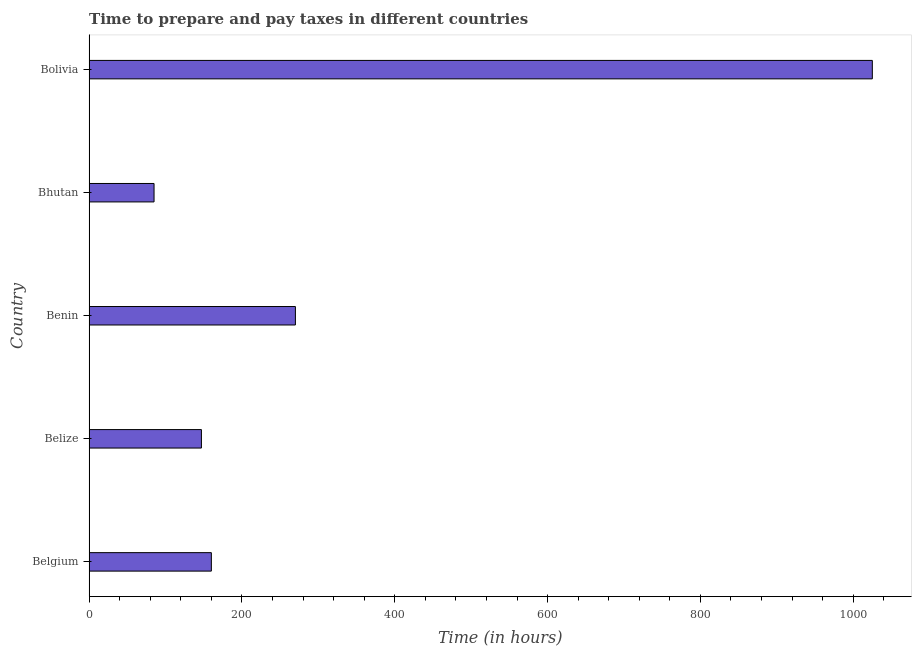Does the graph contain any zero values?
Your answer should be very brief. No. What is the title of the graph?
Make the answer very short. Time to prepare and pay taxes in different countries. What is the label or title of the X-axis?
Offer a very short reply. Time (in hours). What is the label or title of the Y-axis?
Keep it short and to the point. Country. What is the time to prepare and pay taxes in Bolivia?
Your answer should be very brief. 1025. Across all countries, what is the maximum time to prepare and pay taxes?
Provide a short and direct response. 1025. In which country was the time to prepare and pay taxes maximum?
Your answer should be compact. Bolivia. In which country was the time to prepare and pay taxes minimum?
Offer a very short reply. Bhutan. What is the sum of the time to prepare and pay taxes?
Keep it short and to the point. 1687. What is the difference between the time to prepare and pay taxes in Benin and Bhutan?
Keep it short and to the point. 185. What is the average time to prepare and pay taxes per country?
Your response must be concise. 337.4. What is the median time to prepare and pay taxes?
Provide a short and direct response. 160. In how many countries, is the time to prepare and pay taxes greater than 200 hours?
Your response must be concise. 2. What is the ratio of the time to prepare and pay taxes in Belgium to that in Benin?
Offer a terse response. 0.59. Is the time to prepare and pay taxes in Belize less than that in Benin?
Provide a short and direct response. Yes. Is the difference between the time to prepare and pay taxes in Belize and Bhutan greater than the difference between any two countries?
Your response must be concise. No. What is the difference between the highest and the second highest time to prepare and pay taxes?
Your response must be concise. 755. What is the difference between the highest and the lowest time to prepare and pay taxes?
Make the answer very short. 940. How many bars are there?
Keep it short and to the point. 5. What is the difference between two consecutive major ticks on the X-axis?
Your answer should be very brief. 200. What is the Time (in hours) in Belgium?
Offer a terse response. 160. What is the Time (in hours) of Belize?
Provide a succinct answer. 147. What is the Time (in hours) in Benin?
Keep it short and to the point. 270. What is the Time (in hours) in Bolivia?
Your answer should be compact. 1025. What is the difference between the Time (in hours) in Belgium and Benin?
Keep it short and to the point. -110. What is the difference between the Time (in hours) in Belgium and Bolivia?
Ensure brevity in your answer.  -865. What is the difference between the Time (in hours) in Belize and Benin?
Give a very brief answer. -123. What is the difference between the Time (in hours) in Belize and Bolivia?
Your answer should be compact. -878. What is the difference between the Time (in hours) in Benin and Bhutan?
Your answer should be very brief. 185. What is the difference between the Time (in hours) in Benin and Bolivia?
Provide a short and direct response. -755. What is the difference between the Time (in hours) in Bhutan and Bolivia?
Give a very brief answer. -940. What is the ratio of the Time (in hours) in Belgium to that in Belize?
Give a very brief answer. 1.09. What is the ratio of the Time (in hours) in Belgium to that in Benin?
Keep it short and to the point. 0.59. What is the ratio of the Time (in hours) in Belgium to that in Bhutan?
Your response must be concise. 1.88. What is the ratio of the Time (in hours) in Belgium to that in Bolivia?
Offer a very short reply. 0.16. What is the ratio of the Time (in hours) in Belize to that in Benin?
Provide a succinct answer. 0.54. What is the ratio of the Time (in hours) in Belize to that in Bhutan?
Make the answer very short. 1.73. What is the ratio of the Time (in hours) in Belize to that in Bolivia?
Give a very brief answer. 0.14. What is the ratio of the Time (in hours) in Benin to that in Bhutan?
Provide a succinct answer. 3.18. What is the ratio of the Time (in hours) in Benin to that in Bolivia?
Offer a very short reply. 0.26. What is the ratio of the Time (in hours) in Bhutan to that in Bolivia?
Give a very brief answer. 0.08. 